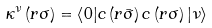<formula> <loc_0><loc_0><loc_500><loc_500>\kappa ^ { \nu } \left ( { r } \sigma \right ) = \left < 0 | c \left ( { r } \bar { \sigma } \right ) c \left ( { r } \sigma \right ) | \nu \right ></formula> 